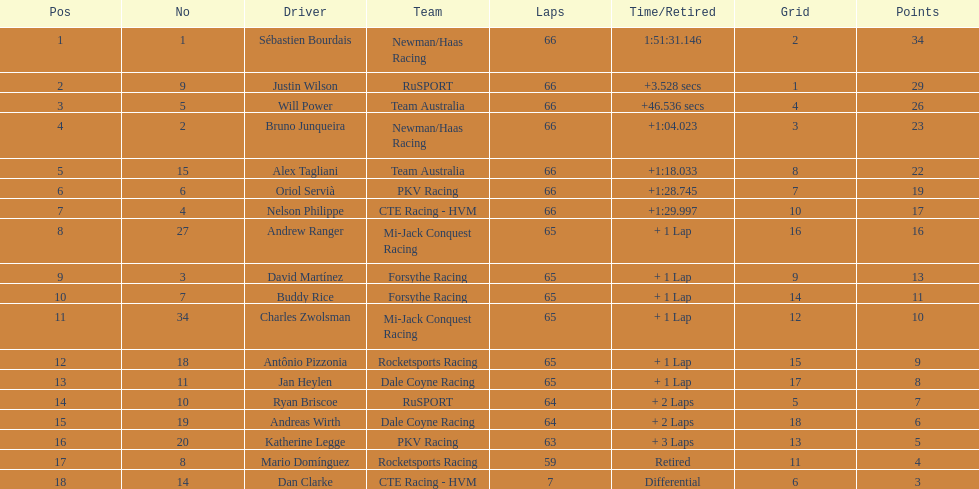Who are all the motorists? Sébastien Bourdais, Justin Wilson, Will Power, Bruno Junqueira, Alex Tagliani, Oriol Servià, Nelson Philippe, Andrew Ranger, David Martínez, Buddy Rice, Charles Zwolsman, Antônio Pizzonia, Jan Heylen, Ryan Briscoe, Andreas Wirth, Katherine Legge, Mario Domínguez, Dan Clarke. What standing did they reach? 1, 2, 3, 4, 5, 6, 7, 8, 9, 10, 11, 12, 13, 14, 15, 16, 17, 18. What is the digit for each motorist? 1, 9, 5, 2, 15, 6, 4, 27, 3, 7, 34, 18, 11, 10, 19, 20, 8, 14. And which competitor's digit and standing align? Sébastien Bourdais. 